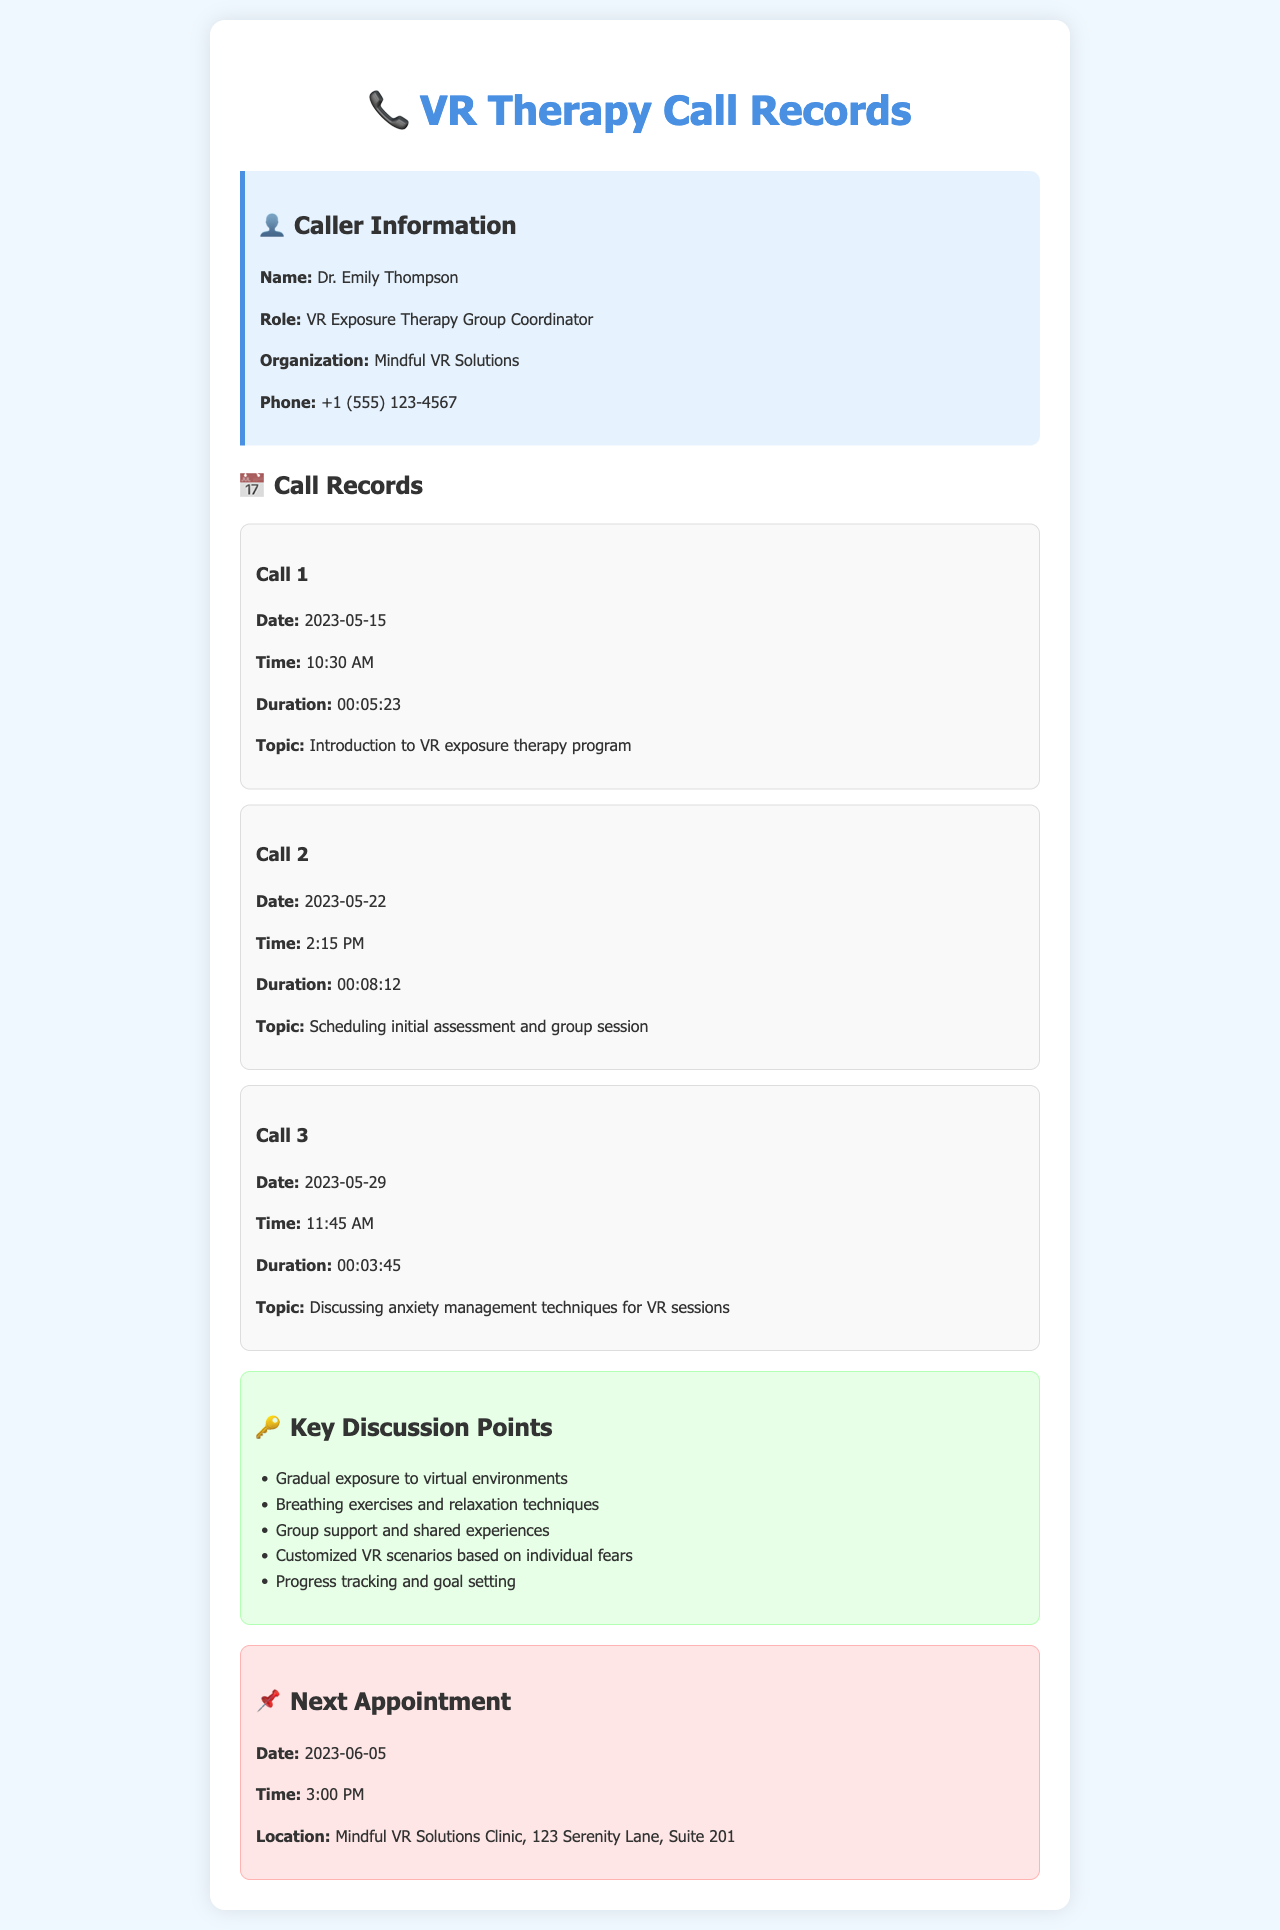What is the name of the caller? The caller's name is provided in the caller information section of the document.
Answer: Dr. Emily Thompson What is the role of the caller? The role of the caller is listed directly in the caller information section.
Answer: VR Exposure Therapy Group Coordinator What is the organization of the caller? The organization is mentioned in the caller information section of the document.
Answer: Mindful VR Solutions What is the phone number of the caller? The phone number is detailed in the caller information section.
Answer: +1 (555) 123-4567 How long did the first call last? The duration of the first call is specified in the call records section of the document.
Answer: 00:05:23 What is the main topic of the second call? The topic is outlined in the call records section for the second call.
Answer: Scheduling initial assessment and group session How many key discussion points are mentioned? The number of key discussion points is found in the key points section of the document.
Answer: Five When is the next appointment scheduled? The date of the next appointment is mentioned in the next appointment section.
Answer: 2023-06-05 Where will the next appointment take place? The location of the next appointment is specified in the next appointment section.
Answer: Mindful VR Solutions Clinic, 123 Serenity Lane, Suite 201 